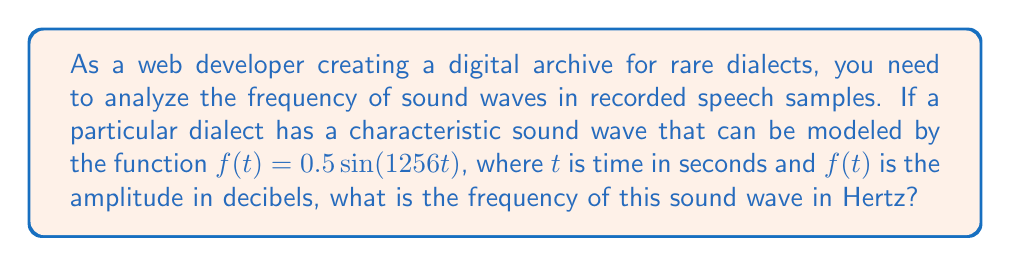Help me with this question. To solve this problem, we'll follow these steps:

1. Recall the general form of a sine function:
   $$f(t) = A \sin(2\pi ft)$$
   where $A$ is the amplitude, $f$ is the frequency in Hertz, and $t$ is time in seconds.

2. Compare our given function to the general form:
   $$0.5 \sin(1256t) = A \sin(2\pi ft)$$

3. Identify that $A = 0.5$ and $1256 = 2\pi f$

4. Solve for $f$:
   $$1256 = 2\pi f$$
   $$f = \frac{1256}{2\pi}$$

5. Calculate the result:
   $$f = \frac{1256}{2\pi} \approx 200 \text{ Hz}$$

The frequency is approximately 200 Hz, which falls within the typical range of human speech frequencies (85 to 255 Hz).
Answer: 200 Hz 